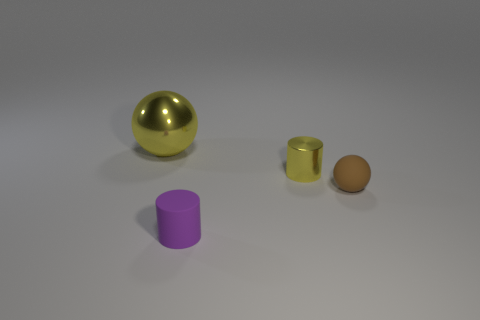There is a tiny cylinder that is in front of the tiny object on the right side of the small yellow cylinder; what color is it?
Your answer should be compact. Purple. There is a thing to the left of the object in front of the matte thing right of the tiny metallic cylinder; how big is it?
Offer a very short reply. Large. Do the small ball and the cylinder left of the tiny yellow shiny thing have the same material?
Your answer should be very brief. Yes. The yellow ball that is made of the same material as the tiny yellow thing is what size?
Offer a very short reply. Large. Are there any brown rubber things that have the same shape as the big yellow shiny object?
Keep it short and to the point. Yes. How many things are yellow metallic objects on the right side of the yellow metal sphere or green matte cubes?
Your answer should be compact. 1. There is a cylinder that is the same color as the large object; what size is it?
Provide a short and direct response. Small. There is a metallic thing that is in front of the big shiny object; is its color the same as the big sphere behind the tiny shiny thing?
Give a very brief answer. Yes. What is the size of the yellow shiny ball?
Your response must be concise. Large. How many large things are purple things or gray metallic balls?
Provide a succinct answer. 0. 